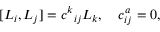<formula> <loc_0><loc_0><loc_500><loc_500>[ L _ { i } , L _ { j } ] = c ^ { k _ { i j } L _ { k } , \quad c _ { i j } ^ { a } = 0 ,</formula> 